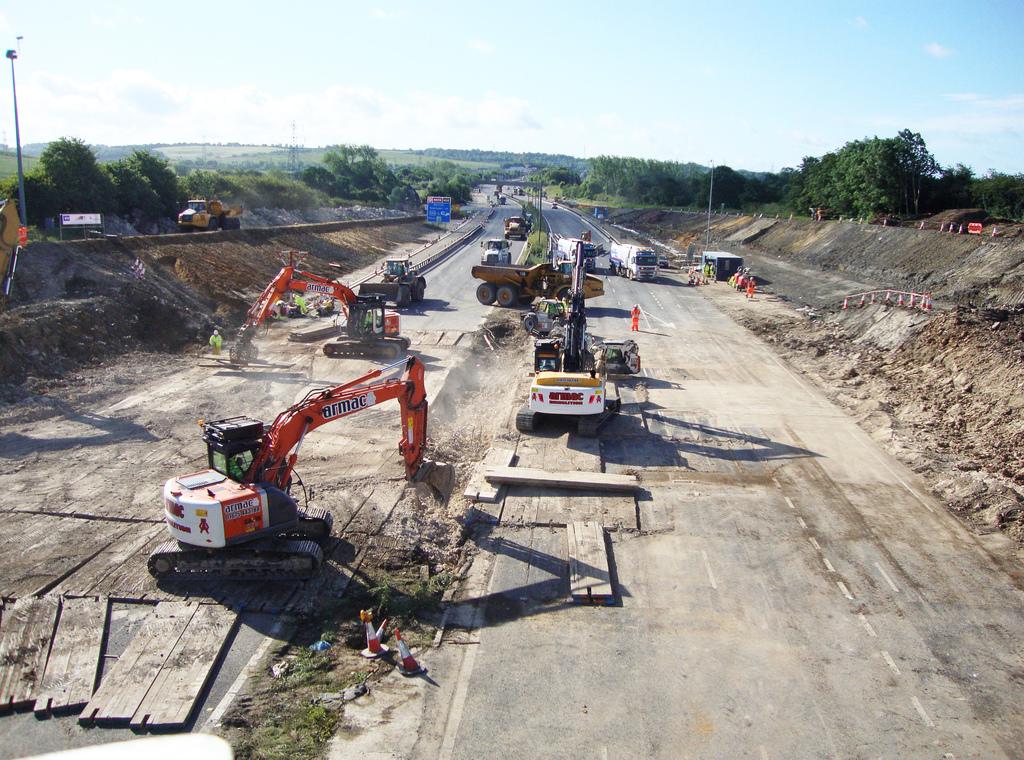What brand is the orange machinr?
Your answer should be compact. Armac. 